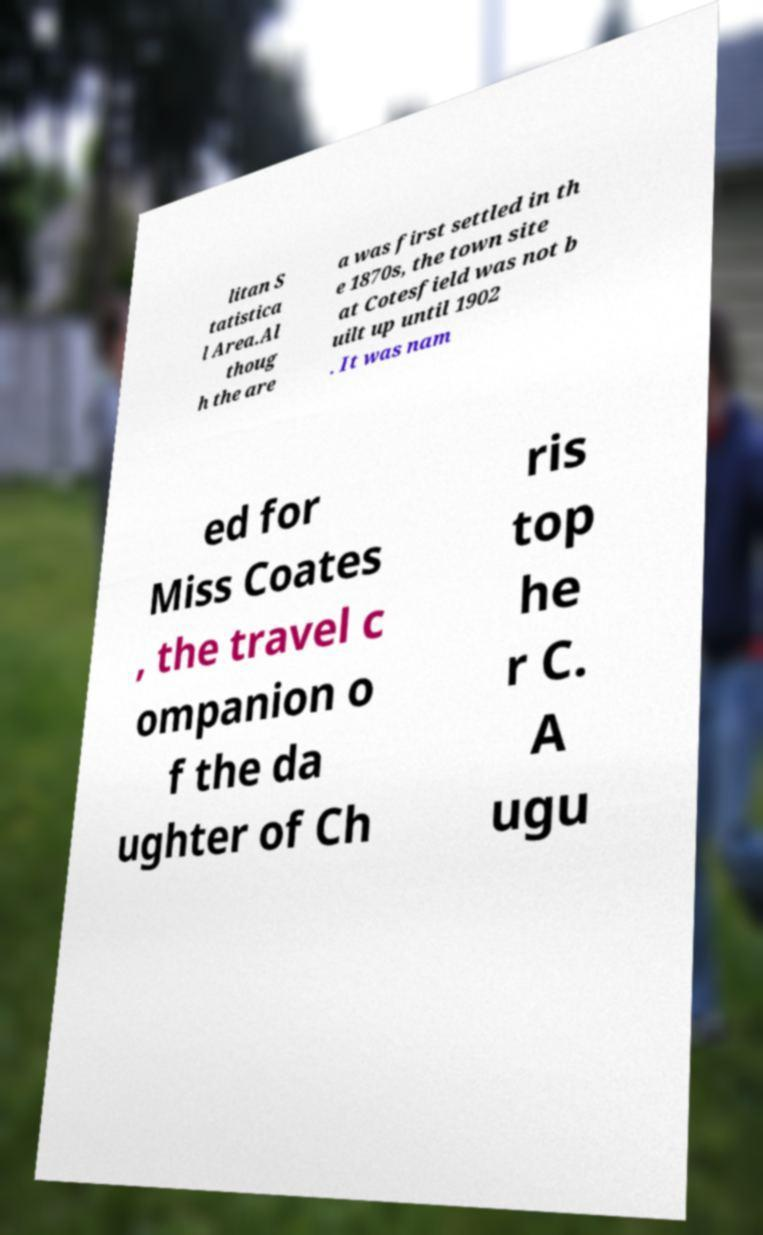I need the written content from this picture converted into text. Can you do that? litan S tatistica l Area.Al thoug h the are a was first settled in th e 1870s, the town site at Cotesfield was not b uilt up until 1902 . It was nam ed for Miss Coates , the travel c ompanion o f the da ughter of Ch ris top he r C. A ugu 